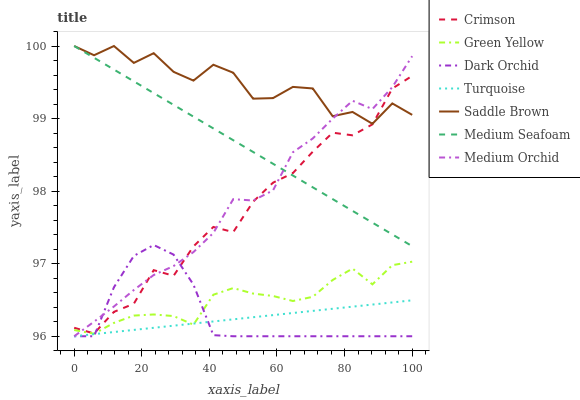Does Turquoise have the minimum area under the curve?
Answer yes or no. Yes. Does Saddle Brown have the maximum area under the curve?
Answer yes or no. Yes. Does Medium Orchid have the minimum area under the curve?
Answer yes or no. No. Does Medium Orchid have the maximum area under the curve?
Answer yes or no. No. Is Turquoise the smoothest?
Answer yes or no. Yes. Is Saddle Brown the roughest?
Answer yes or no. Yes. Is Medium Orchid the smoothest?
Answer yes or no. No. Is Medium Orchid the roughest?
Answer yes or no. No. Does Turquoise have the lowest value?
Answer yes or no. Yes. Does Medium Seafoam have the lowest value?
Answer yes or no. No. Does Saddle Brown have the highest value?
Answer yes or no. Yes. Does Medium Orchid have the highest value?
Answer yes or no. No. Is Turquoise less than Saddle Brown?
Answer yes or no. Yes. Is Medium Seafoam greater than Green Yellow?
Answer yes or no. Yes. Does Saddle Brown intersect Medium Seafoam?
Answer yes or no. Yes. Is Saddle Brown less than Medium Seafoam?
Answer yes or no. No. Is Saddle Brown greater than Medium Seafoam?
Answer yes or no. No. Does Turquoise intersect Saddle Brown?
Answer yes or no. No. 